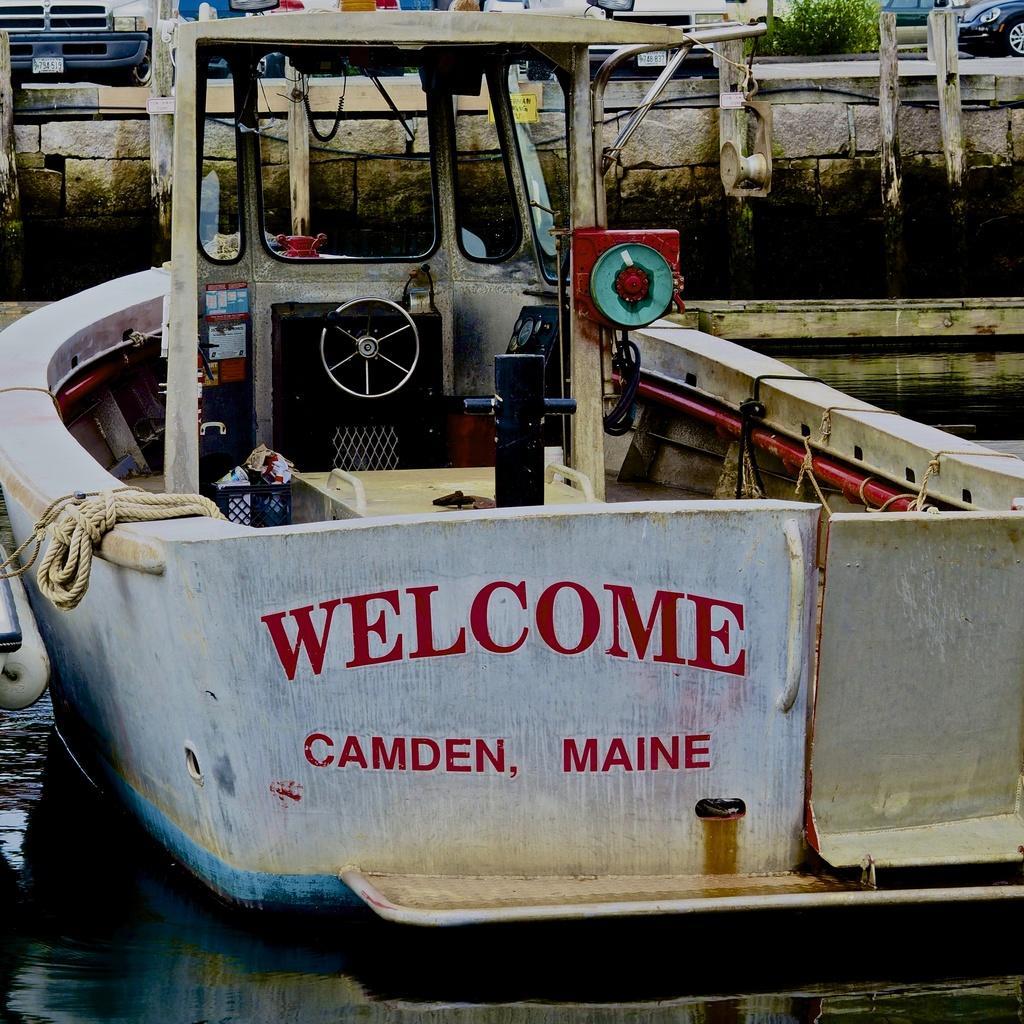Can you describe this image briefly? In the center of the image there is ship. At the bottom of the image there is water. 